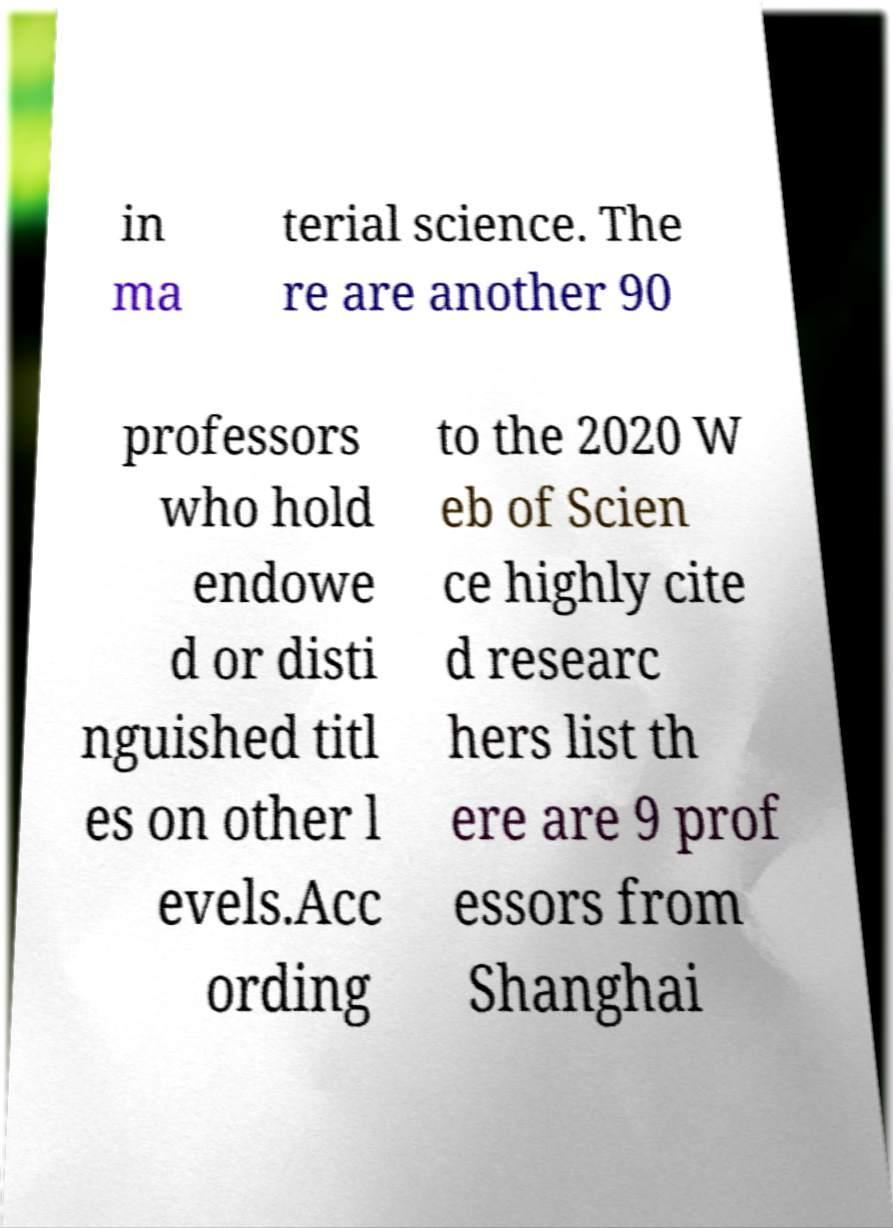Can you read and provide the text displayed in the image?This photo seems to have some interesting text. Can you extract and type it out for me? in ma terial science. The re are another 90 professors who hold endowe d or disti nguished titl es on other l evels.Acc ording to the 2020 W eb of Scien ce highly cite d researc hers list th ere are 9 prof essors from Shanghai 